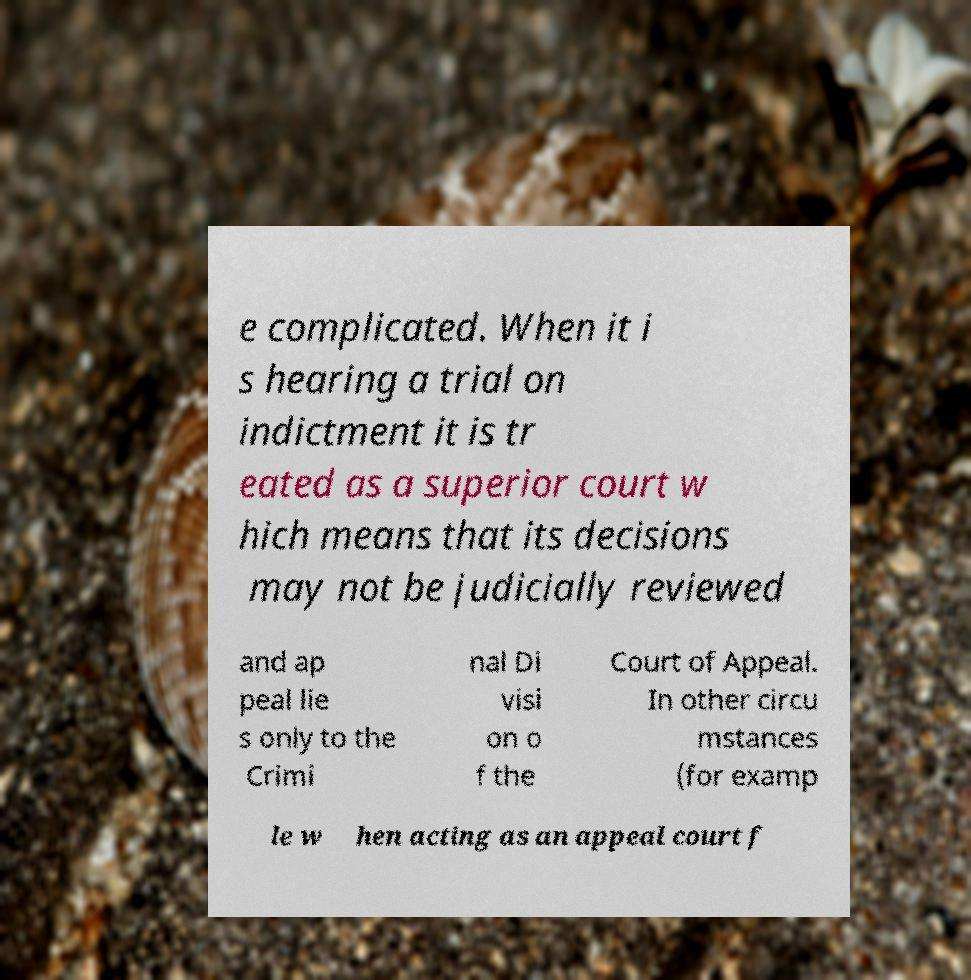Can you read and provide the text displayed in the image?This photo seems to have some interesting text. Can you extract and type it out for me? e complicated. When it i s hearing a trial on indictment it is tr eated as a superior court w hich means that its decisions may not be judicially reviewed and ap peal lie s only to the Crimi nal Di visi on o f the Court of Appeal. In other circu mstances (for examp le w hen acting as an appeal court f 